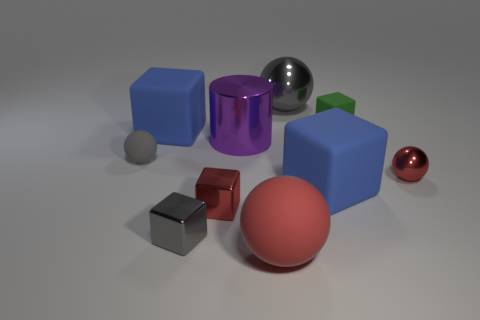Subtract all gray shiny blocks. How many blocks are left? 4 Subtract 2 blocks. How many blocks are left? 3 Subtract all purple cubes. Subtract all brown spheres. How many cubes are left? 5 Subtract all cylinders. How many objects are left? 9 Add 3 gray metallic spheres. How many gray metallic spheres are left? 4 Add 3 tiny shiny balls. How many tiny shiny balls exist? 4 Subtract 0 cyan spheres. How many objects are left? 10 Subtract all tiny metallic blocks. Subtract all gray blocks. How many objects are left? 7 